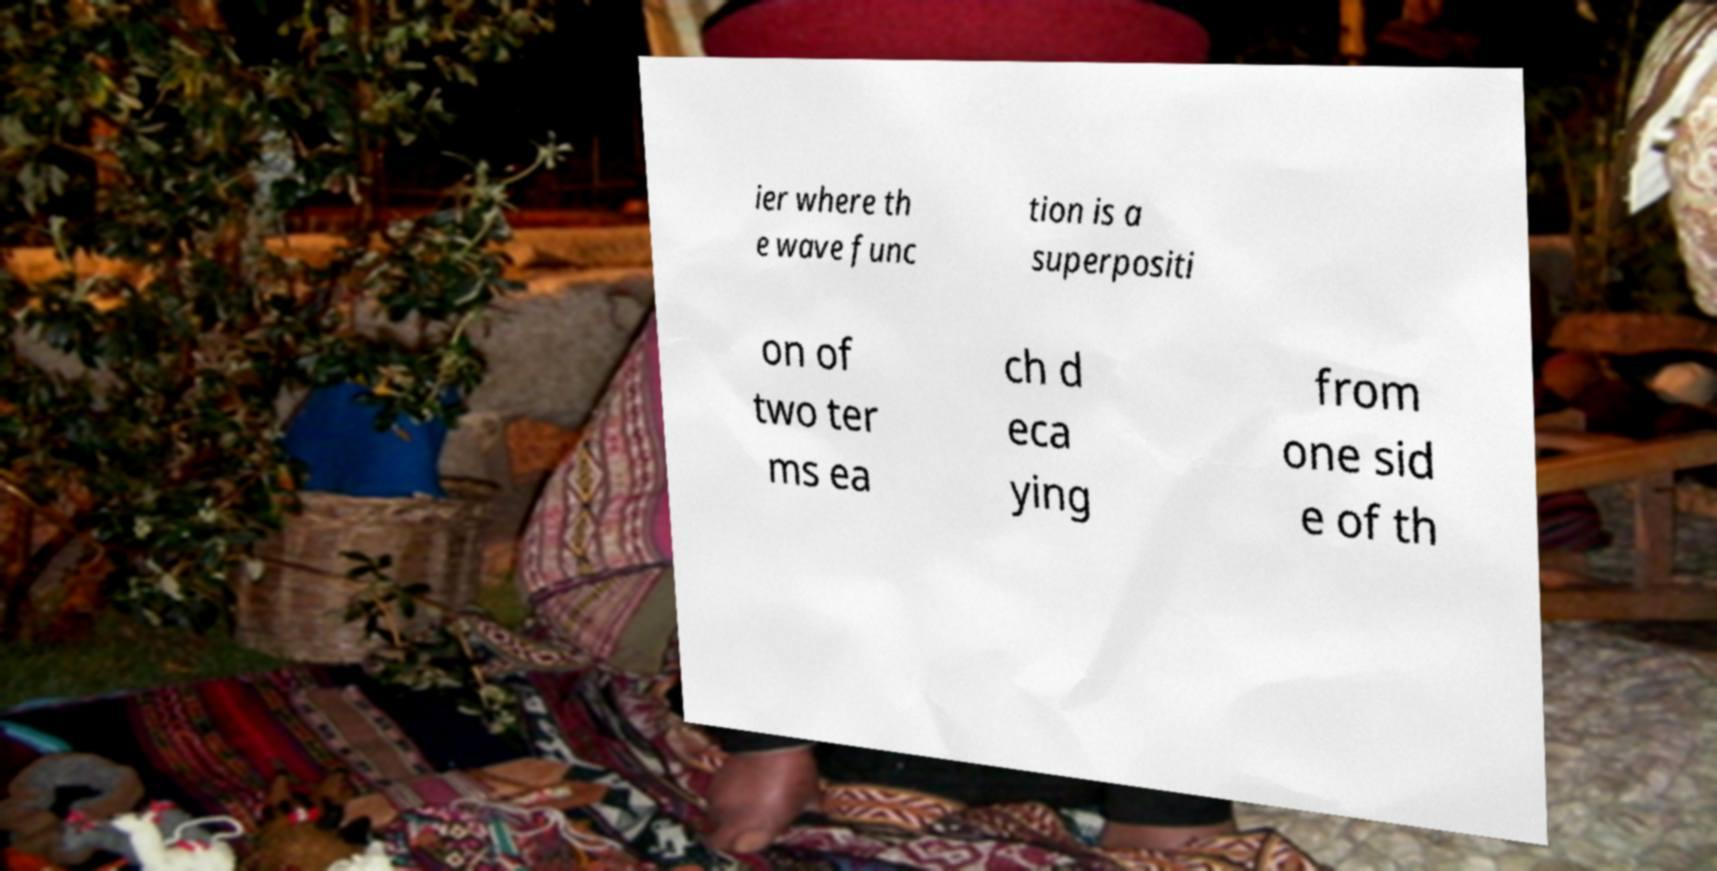Can you read and provide the text displayed in the image?This photo seems to have some interesting text. Can you extract and type it out for me? ier where th e wave func tion is a superpositi on of two ter ms ea ch d eca ying from one sid e of th 